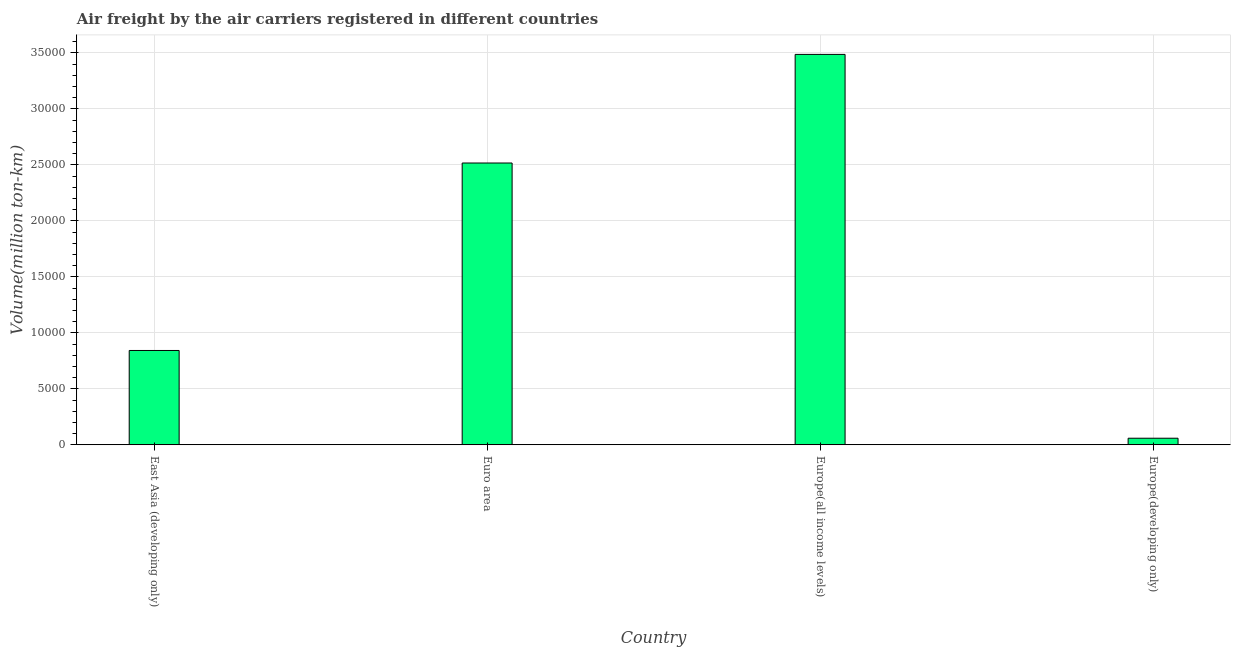Does the graph contain any zero values?
Provide a succinct answer. No. Does the graph contain grids?
Give a very brief answer. Yes. What is the title of the graph?
Offer a very short reply. Air freight by the air carriers registered in different countries. What is the label or title of the X-axis?
Offer a terse response. Country. What is the label or title of the Y-axis?
Your answer should be compact. Volume(million ton-km). What is the air freight in East Asia (developing only)?
Give a very brief answer. 8423.74. Across all countries, what is the maximum air freight?
Provide a short and direct response. 3.49e+04. Across all countries, what is the minimum air freight?
Offer a very short reply. 586.49. In which country was the air freight maximum?
Your answer should be very brief. Europe(all income levels). In which country was the air freight minimum?
Keep it short and to the point. Europe(developing only). What is the sum of the air freight?
Provide a short and direct response. 6.90e+04. What is the difference between the air freight in East Asia (developing only) and Europe(developing only)?
Your answer should be compact. 7837.25. What is the average air freight per country?
Keep it short and to the point. 1.73e+04. What is the median air freight?
Provide a short and direct response. 1.68e+04. What is the ratio of the air freight in East Asia (developing only) to that in Europe(developing only)?
Offer a terse response. 14.36. Is the air freight in Europe(all income levels) less than that in Europe(developing only)?
Offer a terse response. No. Is the difference between the air freight in Europe(all income levels) and Europe(developing only) greater than the difference between any two countries?
Make the answer very short. Yes. What is the difference between the highest and the second highest air freight?
Keep it short and to the point. 9699.62. Is the sum of the air freight in East Asia (developing only) and Euro area greater than the maximum air freight across all countries?
Ensure brevity in your answer.  No. What is the difference between the highest and the lowest air freight?
Give a very brief answer. 3.43e+04. How many bars are there?
Ensure brevity in your answer.  4. Are all the bars in the graph horizontal?
Offer a very short reply. No. How many countries are there in the graph?
Your answer should be very brief. 4. What is the difference between two consecutive major ticks on the Y-axis?
Offer a terse response. 5000. What is the Volume(million ton-km) in East Asia (developing only)?
Offer a very short reply. 8423.74. What is the Volume(million ton-km) of Euro area?
Offer a terse response. 2.52e+04. What is the Volume(million ton-km) of Europe(all income levels)?
Ensure brevity in your answer.  3.49e+04. What is the Volume(million ton-km) in Europe(developing only)?
Make the answer very short. 586.49. What is the difference between the Volume(million ton-km) in East Asia (developing only) and Euro area?
Make the answer very short. -1.67e+04. What is the difference between the Volume(million ton-km) in East Asia (developing only) and Europe(all income levels)?
Make the answer very short. -2.64e+04. What is the difference between the Volume(million ton-km) in East Asia (developing only) and Europe(developing only)?
Your response must be concise. 7837.25. What is the difference between the Volume(million ton-km) in Euro area and Europe(all income levels)?
Your answer should be very brief. -9699.62. What is the difference between the Volume(million ton-km) in Euro area and Europe(developing only)?
Offer a terse response. 2.46e+04. What is the difference between the Volume(million ton-km) in Europe(all income levels) and Europe(developing only)?
Ensure brevity in your answer.  3.43e+04. What is the ratio of the Volume(million ton-km) in East Asia (developing only) to that in Euro area?
Your response must be concise. 0.34. What is the ratio of the Volume(million ton-km) in East Asia (developing only) to that in Europe(all income levels)?
Provide a succinct answer. 0.24. What is the ratio of the Volume(million ton-km) in East Asia (developing only) to that in Europe(developing only)?
Provide a succinct answer. 14.36. What is the ratio of the Volume(million ton-km) in Euro area to that in Europe(all income levels)?
Your answer should be very brief. 0.72. What is the ratio of the Volume(million ton-km) in Euro area to that in Europe(developing only)?
Your answer should be very brief. 42.91. What is the ratio of the Volume(million ton-km) in Europe(all income levels) to that in Europe(developing only)?
Offer a very short reply. 59.45. 